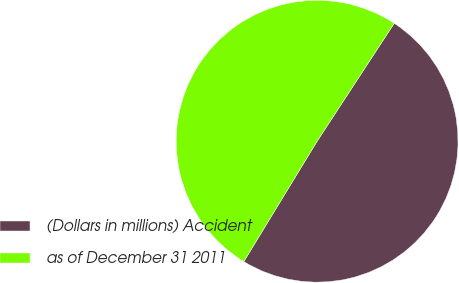Convert chart. <chart><loc_0><loc_0><loc_500><loc_500><pie_chart><fcel>(Dollars in millions) Accident<fcel>as of December 31 2011<nl><fcel>49.49%<fcel>50.51%<nl></chart> 